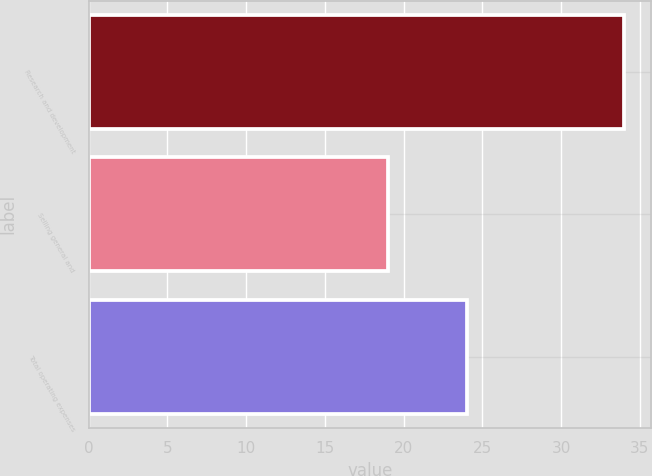<chart> <loc_0><loc_0><loc_500><loc_500><bar_chart><fcel>Research and development<fcel>Selling general and<fcel>Total operating expenses<nl><fcel>34<fcel>19<fcel>24<nl></chart> 